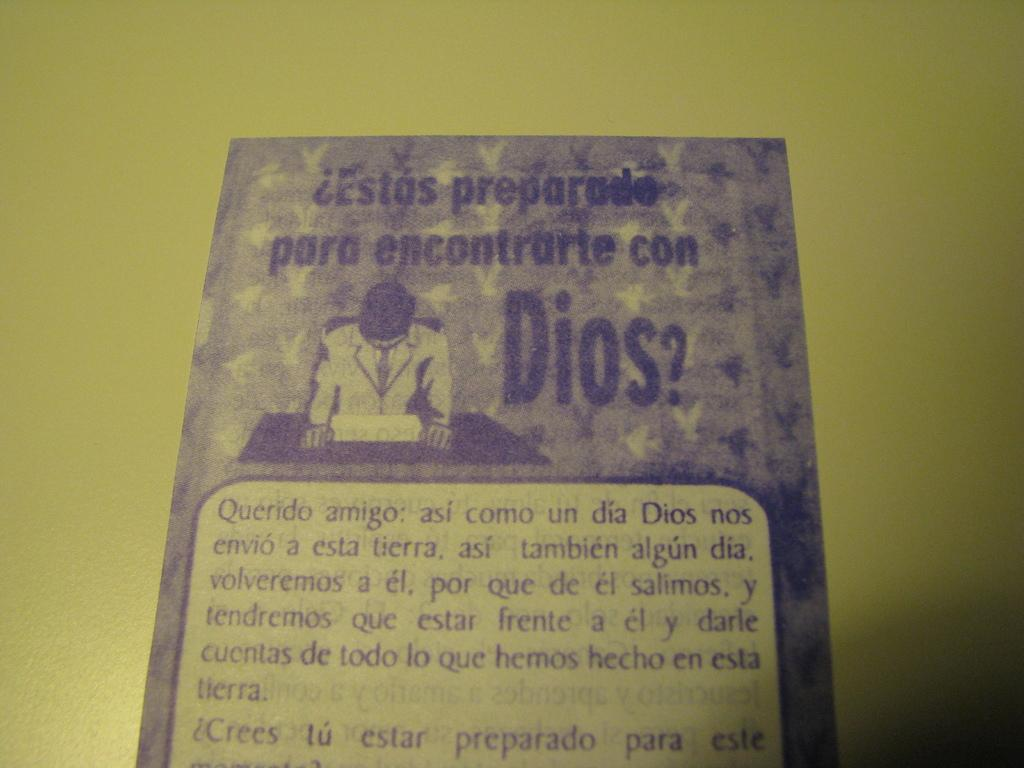<image>
Share a concise interpretation of the image provided. A small pamphlet that says are you ready to meet god written in spanish. 